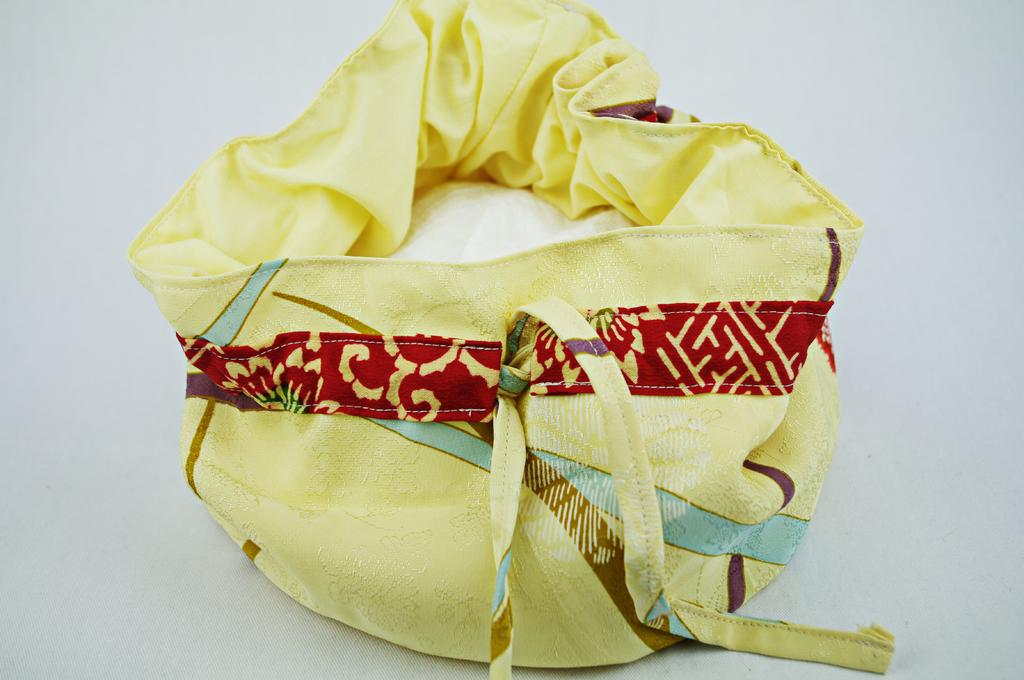What color is the bag that is visible in the image? There is a yellow bag in the image. What type of advice can be seen written on the yellow bag in the image? There is no advice visible on the yellow bag in the image; it is simply a yellow bag. 